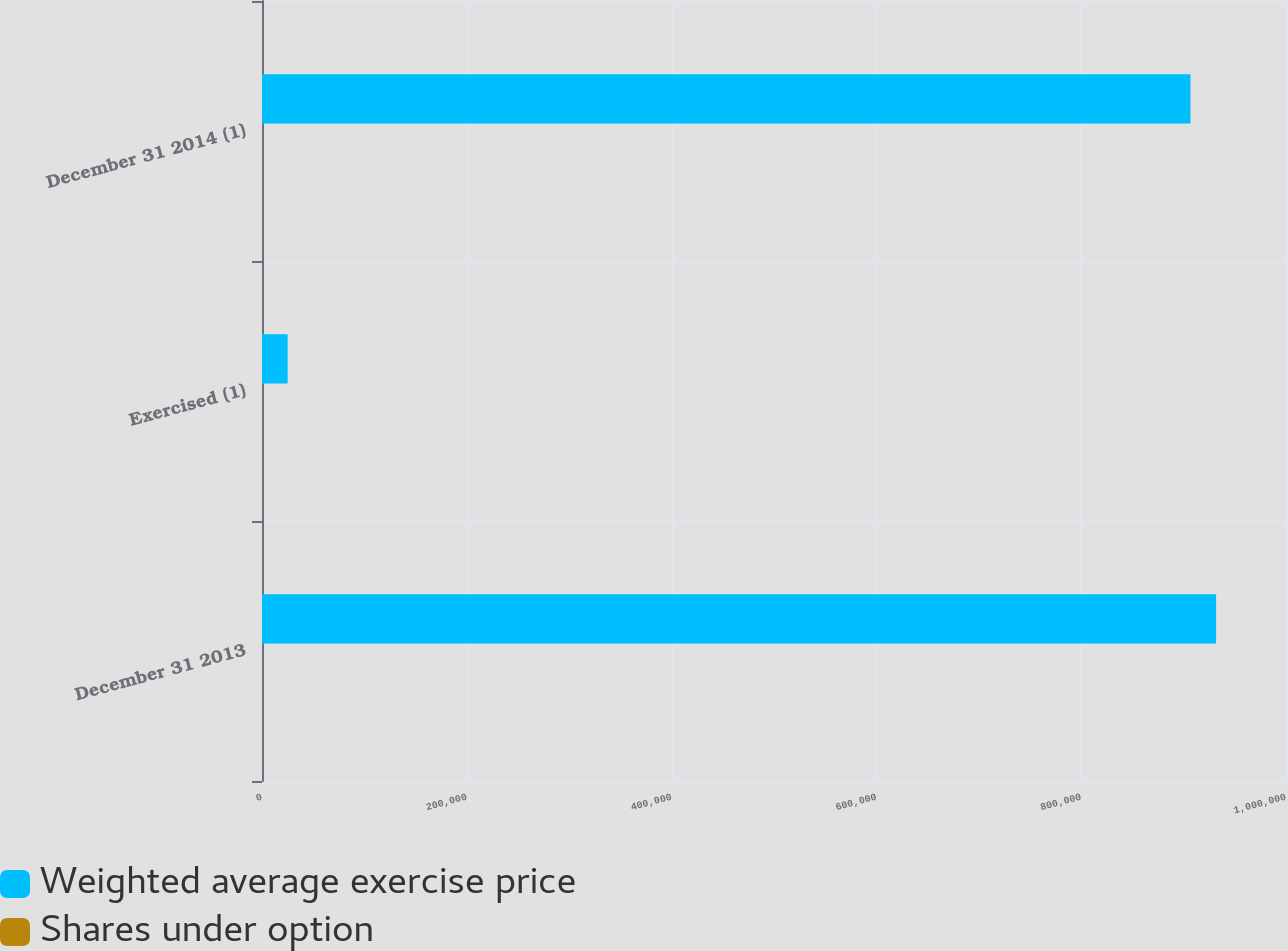Convert chart to OTSL. <chart><loc_0><loc_0><loc_500><loc_500><stacked_bar_chart><ecel><fcel>December 31 2013<fcel>Exercised (1)<fcel>December 31 2014 (1)<nl><fcel>Weighted average exercise price<fcel>931758<fcel>25039<fcel>906719<nl><fcel>Shares under option<fcel>167.76<fcel>167.76<fcel>167.76<nl></chart> 